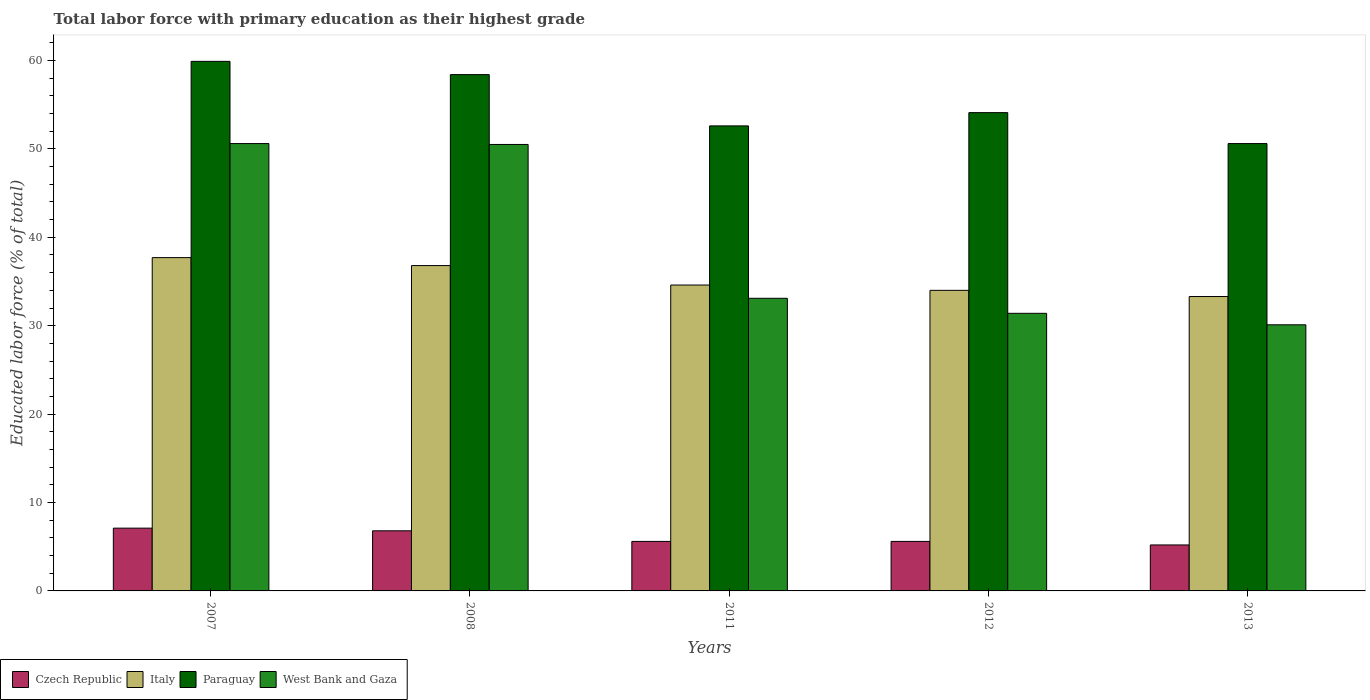How many groups of bars are there?
Offer a very short reply. 5. Are the number of bars on each tick of the X-axis equal?
Offer a very short reply. Yes. How many bars are there on the 5th tick from the right?
Give a very brief answer. 4. In how many cases, is the number of bars for a given year not equal to the number of legend labels?
Offer a very short reply. 0. What is the percentage of total labor force with primary education in West Bank and Gaza in 2013?
Your answer should be compact. 30.1. Across all years, what is the maximum percentage of total labor force with primary education in West Bank and Gaza?
Your response must be concise. 50.6. Across all years, what is the minimum percentage of total labor force with primary education in West Bank and Gaza?
Offer a terse response. 30.1. In which year was the percentage of total labor force with primary education in West Bank and Gaza maximum?
Give a very brief answer. 2007. In which year was the percentage of total labor force with primary education in Italy minimum?
Give a very brief answer. 2013. What is the total percentage of total labor force with primary education in West Bank and Gaza in the graph?
Offer a very short reply. 195.7. What is the difference between the percentage of total labor force with primary education in West Bank and Gaza in 2011 and that in 2013?
Offer a very short reply. 3. What is the difference between the percentage of total labor force with primary education in Italy in 2012 and the percentage of total labor force with primary education in West Bank and Gaza in 2013?
Keep it short and to the point. 3.9. What is the average percentage of total labor force with primary education in Paraguay per year?
Your answer should be very brief. 55.12. In the year 2012, what is the difference between the percentage of total labor force with primary education in West Bank and Gaza and percentage of total labor force with primary education in Paraguay?
Provide a short and direct response. -22.7. What is the ratio of the percentage of total labor force with primary education in West Bank and Gaza in 2011 to that in 2012?
Give a very brief answer. 1.05. Is the percentage of total labor force with primary education in Paraguay in 2008 less than that in 2011?
Provide a succinct answer. No. Is the difference between the percentage of total labor force with primary education in West Bank and Gaza in 2007 and 2012 greater than the difference between the percentage of total labor force with primary education in Paraguay in 2007 and 2012?
Provide a short and direct response. Yes. What is the difference between the highest and the second highest percentage of total labor force with primary education in Czech Republic?
Offer a terse response. 0.3. What is the difference between the highest and the lowest percentage of total labor force with primary education in Italy?
Make the answer very short. 4.4. Is it the case that in every year, the sum of the percentage of total labor force with primary education in West Bank and Gaza and percentage of total labor force with primary education in Italy is greater than the sum of percentage of total labor force with primary education in Paraguay and percentage of total labor force with primary education in Czech Republic?
Your response must be concise. No. What does the 4th bar from the left in 2008 represents?
Make the answer very short. West Bank and Gaza. Does the graph contain grids?
Offer a very short reply. No. What is the title of the graph?
Provide a short and direct response. Total labor force with primary education as their highest grade. Does "Afghanistan" appear as one of the legend labels in the graph?
Make the answer very short. No. What is the label or title of the X-axis?
Provide a succinct answer. Years. What is the label or title of the Y-axis?
Ensure brevity in your answer.  Educated labor force (% of total). What is the Educated labor force (% of total) of Czech Republic in 2007?
Keep it short and to the point. 7.1. What is the Educated labor force (% of total) in Italy in 2007?
Keep it short and to the point. 37.7. What is the Educated labor force (% of total) in Paraguay in 2007?
Make the answer very short. 59.9. What is the Educated labor force (% of total) of West Bank and Gaza in 2007?
Keep it short and to the point. 50.6. What is the Educated labor force (% of total) of Czech Republic in 2008?
Keep it short and to the point. 6.8. What is the Educated labor force (% of total) in Italy in 2008?
Ensure brevity in your answer.  36.8. What is the Educated labor force (% of total) of Paraguay in 2008?
Ensure brevity in your answer.  58.4. What is the Educated labor force (% of total) in West Bank and Gaza in 2008?
Provide a short and direct response. 50.5. What is the Educated labor force (% of total) of Czech Republic in 2011?
Your answer should be very brief. 5.6. What is the Educated labor force (% of total) of Italy in 2011?
Provide a short and direct response. 34.6. What is the Educated labor force (% of total) of Paraguay in 2011?
Your answer should be very brief. 52.6. What is the Educated labor force (% of total) in West Bank and Gaza in 2011?
Keep it short and to the point. 33.1. What is the Educated labor force (% of total) in Czech Republic in 2012?
Make the answer very short. 5.6. What is the Educated labor force (% of total) of Italy in 2012?
Your answer should be compact. 34. What is the Educated labor force (% of total) in Paraguay in 2012?
Give a very brief answer. 54.1. What is the Educated labor force (% of total) in West Bank and Gaza in 2012?
Make the answer very short. 31.4. What is the Educated labor force (% of total) in Czech Republic in 2013?
Keep it short and to the point. 5.2. What is the Educated labor force (% of total) in Italy in 2013?
Provide a succinct answer. 33.3. What is the Educated labor force (% of total) of Paraguay in 2013?
Offer a terse response. 50.6. What is the Educated labor force (% of total) of West Bank and Gaza in 2013?
Your answer should be compact. 30.1. Across all years, what is the maximum Educated labor force (% of total) of Czech Republic?
Ensure brevity in your answer.  7.1. Across all years, what is the maximum Educated labor force (% of total) in Italy?
Your answer should be compact. 37.7. Across all years, what is the maximum Educated labor force (% of total) in Paraguay?
Offer a terse response. 59.9. Across all years, what is the maximum Educated labor force (% of total) in West Bank and Gaza?
Make the answer very short. 50.6. Across all years, what is the minimum Educated labor force (% of total) of Czech Republic?
Offer a terse response. 5.2. Across all years, what is the minimum Educated labor force (% of total) of Italy?
Your answer should be very brief. 33.3. Across all years, what is the minimum Educated labor force (% of total) in Paraguay?
Keep it short and to the point. 50.6. Across all years, what is the minimum Educated labor force (% of total) in West Bank and Gaza?
Your answer should be compact. 30.1. What is the total Educated labor force (% of total) of Czech Republic in the graph?
Your answer should be compact. 30.3. What is the total Educated labor force (% of total) in Italy in the graph?
Provide a short and direct response. 176.4. What is the total Educated labor force (% of total) in Paraguay in the graph?
Offer a terse response. 275.6. What is the total Educated labor force (% of total) in West Bank and Gaza in the graph?
Ensure brevity in your answer.  195.7. What is the difference between the Educated labor force (% of total) in West Bank and Gaza in 2007 and that in 2008?
Provide a succinct answer. 0.1. What is the difference between the Educated labor force (% of total) in Italy in 2007 and that in 2011?
Your answer should be compact. 3.1. What is the difference between the Educated labor force (% of total) of Paraguay in 2007 and that in 2011?
Ensure brevity in your answer.  7.3. What is the difference between the Educated labor force (% of total) in West Bank and Gaza in 2007 and that in 2011?
Ensure brevity in your answer.  17.5. What is the difference between the Educated labor force (% of total) of West Bank and Gaza in 2007 and that in 2012?
Make the answer very short. 19.2. What is the difference between the Educated labor force (% of total) of Italy in 2007 and that in 2013?
Offer a terse response. 4.4. What is the difference between the Educated labor force (% of total) of West Bank and Gaza in 2007 and that in 2013?
Your response must be concise. 20.5. What is the difference between the Educated labor force (% of total) in Czech Republic in 2008 and that in 2011?
Your answer should be compact. 1.2. What is the difference between the Educated labor force (% of total) in Italy in 2008 and that in 2011?
Offer a terse response. 2.2. What is the difference between the Educated labor force (% of total) of Paraguay in 2008 and that in 2011?
Offer a very short reply. 5.8. What is the difference between the Educated labor force (% of total) of Paraguay in 2008 and that in 2012?
Your answer should be compact. 4.3. What is the difference between the Educated labor force (% of total) of West Bank and Gaza in 2008 and that in 2012?
Make the answer very short. 19.1. What is the difference between the Educated labor force (% of total) of Czech Republic in 2008 and that in 2013?
Provide a short and direct response. 1.6. What is the difference between the Educated labor force (% of total) of Paraguay in 2008 and that in 2013?
Your answer should be very brief. 7.8. What is the difference between the Educated labor force (% of total) in West Bank and Gaza in 2008 and that in 2013?
Your answer should be compact. 20.4. What is the difference between the Educated labor force (% of total) of Czech Republic in 2011 and that in 2012?
Your answer should be compact. 0. What is the difference between the Educated labor force (% of total) of Czech Republic in 2011 and that in 2013?
Offer a terse response. 0.4. What is the difference between the Educated labor force (% of total) of Italy in 2011 and that in 2013?
Offer a very short reply. 1.3. What is the difference between the Educated labor force (% of total) in West Bank and Gaza in 2011 and that in 2013?
Provide a short and direct response. 3. What is the difference between the Educated labor force (% of total) of Czech Republic in 2012 and that in 2013?
Give a very brief answer. 0.4. What is the difference between the Educated labor force (% of total) in Paraguay in 2012 and that in 2013?
Provide a succinct answer. 3.5. What is the difference between the Educated labor force (% of total) in Czech Republic in 2007 and the Educated labor force (% of total) in Italy in 2008?
Provide a succinct answer. -29.7. What is the difference between the Educated labor force (% of total) in Czech Republic in 2007 and the Educated labor force (% of total) in Paraguay in 2008?
Offer a terse response. -51.3. What is the difference between the Educated labor force (% of total) in Czech Republic in 2007 and the Educated labor force (% of total) in West Bank and Gaza in 2008?
Offer a terse response. -43.4. What is the difference between the Educated labor force (% of total) of Italy in 2007 and the Educated labor force (% of total) of Paraguay in 2008?
Your answer should be very brief. -20.7. What is the difference between the Educated labor force (% of total) of Paraguay in 2007 and the Educated labor force (% of total) of West Bank and Gaza in 2008?
Your answer should be compact. 9.4. What is the difference between the Educated labor force (% of total) in Czech Republic in 2007 and the Educated labor force (% of total) in Italy in 2011?
Provide a succinct answer. -27.5. What is the difference between the Educated labor force (% of total) in Czech Republic in 2007 and the Educated labor force (% of total) in Paraguay in 2011?
Offer a terse response. -45.5. What is the difference between the Educated labor force (% of total) in Czech Republic in 2007 and the Educated labor force (% of total) in West Bank and Gaza in 2011?
Give a very brief answer. -26. What is the difference between the Educated labor force (% of total) of Italy in 2007 and the Educated labor force (% of total) of Paraguay in 2011?
Offer a very short reply. -14.9. What is the difference between the Educated labor force (% of total) of Paraguay in 2007 and the Educated labor force (% of total) of West Bank and Gaza in 2011?
Your response must be concise. 26.8. What is the difference between the Educated labor force (% of total) of Czech Republic in 2007 and the Educated labor force (% of total) of Italy in 2012?
Provide a short and direct response. -26.9. What is the difference between the Educated labor force (% of total) of Czech Republic in 2007 and the Educated labor force (% of total) of Paraguay in 2012?
Provide a short and direct response. -47. What is the difference between the Educated labor force (% of total) in Czech Republic in 2007 and the Educated labor force (% of total) in West Bank and Gaza in 2012?
Make the answer very short. -24.3. What is the difference between the Educated labor force (% of total) in Italy in 2007 and the Educated labor force (% of total) in Paraguay in 2012?
Provide a short and direct response. -16.4. What is the difference between the Educated labor force (% of total) of Paraguay in 2007 and the Educated labor force (% of total) of West Bank and Gaza in 2012?
Your answer should be compact. 28.5. What is the difference between the Educated labor force (% of total) of Czech Republic in 2007 and the Educated labor force (% of total) of Italy in 2013?
Your answer should be very brief. -26.2. What is the difference between the Educated labor force (% of total) of Czech Republic in 2007 and the Educated labor force (% of total) of Paraguay in 2013?
Provide a succinct answer. -43.5. What is the difference between the Educated labor force (% of total) in Czech Republic in 2007 and the Educated labor force (% of total) in West Bank and Gaza in 2013?
Your response must be concise. -23. What is the difference between the Educated labor force (% of total) in Paraguay in 2007 and the Educated labor force (% of total) in West Bank and Gaza in 2013?
Provide a succinct answer. 29.8. What is the difference between the Educated labor force (% of total) of Czech Republic in 2008 and the Educated labor force (% of total) of Italy in 2011?
Offer a very short reply. -27.8. What is the difference between the Educated labor force (% of total) in Czech Republic in 2008 and the Educated labor force (% of total) in Paraguay in 2011?
Your answer should be compact. -45.8. What is the difference between the Educated labor force (% of total) of Czech Republic in 2008 and the Educated labor force (% of total) of West Bank and Gaza in 2011?
Your response must be concise. -26.3. What is the difference between the Educated labor force (% of total) of Italy in 2008 and the Educated labor force (% of total) of Paraguay in 2011?
Your answer should be very brief. -15.8. What is the difference between the Educated labor force (% of total) in Italy in 2008 and the Educated labor force (% of total) in West Bank and Gaza in 2011?
Your answer should be compact. 3.7. What is the difference between the Educated labor force (% of total) in Paraguay in 2008 and the Educated labor force (% of total) in West Bank and Gaza in 2011?
Provide a succinct answer. 25.3. What is the difference between the Educated labor force (% of total) in Czech Republic in 2008 and the Educated labor force (% of total) in Italy in 2012?
Your response must be concise. -27.2. What is the difference between the Educated labor force (% of total) of Czech Republic in 2008 and the Educated labor force (% of total) of Paraguay in 2012?
Make the answer very short. -47.3. What is the difference between the Educated labor force (% of total) in Czech Republic in 2008 and the Educated labor force (% of total) in West Bank and Gaza in 2012?
Make the answer very short. -24.6. What is the difference between the Educated labor force (% of total) in Italy in 2008 and the Educated labor force (% of total) in Paraguay in 2012?
Offer a terse response. -17.3. What is the difference between the Educated labor force (% of total) in Italy in 2008 and the Educated labor force (% of total) in West Bank and Gaza in 2012?
Provide a succinct answer. 5.4. What is the difference between the Educated labor force (% of total) in Paraguay in 2008 and the Educated labor force (% of total) in West Bank and Gaza in 2012?
Provide a succinct answer. 27. What is the difference between the Educated labor force (% of total) of Czech Republic in 2008 and the Educated labor force (% of total) of Italy in 2013?
Keep it short and to the point. -26.5. What is the difference between the Educated labor force (% of total) in Czech Republic in 2008 and the Educated labor force (% of total) in Paraguay in 2013?
Make the answer very short. -43.8. What is the difference between the Educated labor force (% of total) in Czech Republic in 2008 and the Educated labor force (% of total) in West Bank and Gaza in 2013?
Provide a short and direct response. -23.3. What is the difference between the Educated labor force (% of total) of Italy in 2008 and the Educated labor force (% of total) of Paraguay in 2013?
Your answer should be compact. -13.8. What is the difference between the Educated labor force (% of total) in Italy in 2008 and the Educated labor force (% of total) in West Bank and Gaza in 2013?
Make the answer very short. 6.7. What is the difference between the Educated labor force (% of total) of Paraguay in 2008 and the Educated labor force (% of total) of West Bank and Gaza in 2013?
Keep it short and to the point. 28.3. What is the difference between the Educated labor force (% of total) of Czech Republic in 2011 and the Educated labor force (% of total) of Italy in 2012?
Your answer should be compact. -28.4. What is the difference between the Educated labor force (% of total) of Czech Republic in 2011 and the Educated labor force (% of total) of Paraguay in 2012?
Keep it short and to the point. -48.5. What is the difference between the Educated labor force (% of total) in Czech Republic in 2011 and the Educated labor force (% of total) in West Bank and Gaza in 2012?
Offer a terse response. -25.8. What is the difference between the Educated labor force (% of total) in Italy in 2011 and the Educated labor force (% of total) in Paraguay in 2012?
Give a very brief answer. -19.5. What is the difference between the Educated labor force (% of total) in Paraguay in 2011 and the Educated labor force (% of total) in West Bank and Gaza in 2012?
Your answer should be very brief. 21.2. What is the difference between the Educated labor force (% of total) in Czech Republic in 2011 and the Educated labor force (% of total) in Italy in 2013?
Provide a succinct answer. -27.7. What is the difference between the Educated labor force (% of total) in Czech Republic in 2011 and the Educated labor force (% of total) in Paraguay in 2013?
Your answer should be very brief. -45. What is the difference between the Educated labor force (% of total) of Czech Republic in 2011 and the Educated labor force (% of total) of West Bank and Gaza in 2013?
Keep it short and to the point. -24.5. What is the difference between the Educated labor force (% of total) in Italy in 2011 and the Educated labor force (% of total) in Paraguay in 2013?
Give a very brief answer. -16. What is the difference between the Educated labor force (% of total) of Italy in 2011 and the Educated labor force (% of total) of West Bank and Gaza in 2013?
Ensure brevity in your answer.  4.5. What is the difference between the Educated labor force (% of total) in Paraguay in 2011 and the Educated labor force (% of total) in West Bank and Gaza in 2013?
Ensure brevity in your answer.  22.5. What is the difference between the Educated labor force (% of total) of Czech Republic in 2012 and the Educated labor force (% of total) of Italy in 2013?
Your response must be concise. -27.7. What is the difference between the Educated labor force (% of total) of Czech Republic in 2012 and the Educated labor force (% of total) of Paraguay in 2013?
Offer a very short reply. -45. What is the difference between the Educated labor force (% of total) in Czech Republic in 2012 and the Educated labor force (% of total) in West Bank and Gaza in 2013?
Your answer should be compact. -24.5. What is the difference between the Educated labor force (% of total) of Italy in 2012 and the Educated labor force (% of total) of Paraguay in 2013?
Your answer should be very brief. -16.6. What is the difference between the Educated labor force (% of total) of Italy in 2012 and the Educated labor force (% of total) of West Bank and Gaza in 2013?
Keep it short and to the point. 3.9. What is the average Educated labor force (% of total) of Czech Republic per year?
Provide a succinct answer. 6.06. What is the average Educated labor force (% of total) in Italy per year?
Provide a succinct answer. 35.28. What is the average Educated labor force (% of total) of Paraguay per year?
Give a very brief answer. 55.12. What is the average Educated labor force (% of total) of West Bank and Gaza per year?
Offer a very short reply. 39.14. In the year 2007, what is the difference between the Educated labor force (% of total) of Czech Republic and Educated labor force (% of total) of Italy?
Give a very brief answer. -30.6. In the year 2007, what is the difference between the Educated labor force (% of total) of Czech Republic and Educated labor force (% of total) of Paraguay?
Give a very brief answer. -52.8. In the year 2007, what is the difference between the Educated labor force (% of total) of Czech Republic and Educated labor force (% of total) of West Bank and Gaza?
Offer a terse response. -43.5. In the year 2007, what is the difference between the Educated labor force (% of total) in Italy and Educated labor force (% of total) in Paraguay?
Give a very brief answer. -22.2. In the year 2008, what is the difference between the Educated labor force (% of total) in Czech Republic and Educated labor force (% of total) in Paraguay?
Your response must be concise. -51.6. In the year 2008, what is the difference between the Educated labor force (% of total) in Czech Republic and Educated labor force (% of total) in West Bank and Gaza?
Your answer should be compact. -43.7. In the year 2008, what is the difference between the Educated labor force (% of total) in Italy and Educated labor force (% of total) in Paraguay?
Offer a terse response. -21.6. In the year 2008, what is the difference between the Educated labor force (% of total) in Italy and Educated labor force (% of total) in West Bank and Gaza?
Offer a very short reply. -13.7. In the year 2008, what is the difference between the Educated labor force (% of total) of Paraguay and Educated labor force (% of total) of West Bank and Gaza?
Your answer should be very brief. 7.9. In the year 2011, what is the difference between the Educated labor force (% of total) in Czech Republic and Educated labor force (% of total) in Paraguay?
Give a very brief answer. -47. In the year 2011, what is the difference between the Educated labor force (% of total) in Czech Republic and Educated labor force (% of total) in West Bank and Gaza?
Make the answer very short. -27.5. In the year 2011, what is the difference between the Educated labor force (% of total) of Italy and Educated labor force (% of total) of West Bank and Gaza?
Provide a short and direct response. 1.5. In the year 2012, what is the difference between the Educated labor force (% of total) of Czech Republic and Educated labor force (% of total) of Italy?
Make the answer very short. -28.4. In the year 2012, what is the difference between the Educated labor force (% of total) in Czech Republic and Educated labor force (% of total) in Paraguay?
Make the answer very short. -48.5. In the year 2012, what is the difference between the Educated labor force (% of total) of Czech Republic and Educated labor force (% of total) of West Bank and Gaza?
Ensure brevity in your answer.  -25.8. In the year 2012, what is the difference between the Educated labor force (% of total) of Italy and Educated labor force (% of total) of Paraguay?
Provide a succinct answer. -20.1. In the year 2012, what is the difference between the Educated labor force (% of total) of Paraguay and Educated labor force (% of total) of West Bank and Gaza?
Offer a terse response. 22.7. In the year 2013, what is the difference between the Educated labor force (% of total) in Czech Republic and Educated labor force (% of total) in Italy?
Provide a succinct answer. -28.1. In the year 2013, what is the difference between the Educated labor force (% of total) of Czech Republic and Educated labor force (% of total) of Paraguay?
Provide a succinct answer. -45.4. In the year 2013, what is the difference between the Educated labor force (% of total) in Czech Republic and Educated labor force (% of total) in West Bank and Gaza?
Make the answer very short. -24.9. In the year 2013, what is the difference between the Educated labor force (% of total) in Italy and Educated labor force (% of total) in Paraguay?
Offer a very short reply. -17.3. In the year 2013, what is the difference between the Educated labor force (% of total) of Italy and Educated labor force (% of total) of West Bank and Gaza?
Ensure brevity in your answer.  3.2. In the year 2013, what is the difference between the Educated labor force (% of total) of Paraguay and Educated labor force (% of total) of West Bank and Gaza?
Make the answer very short. 20.5. What is the ratio of the Educated labor force (% of total) of Czech Republic in 2007 to that in 2008?
Provide a succinct answer. 1.04. What is the ratio of the Educated labor force (% of total) in Italy in 2007 to that in 2008?
Offer a very short reply. 1.02. What is the ratio of the Educated labor force (% of total) in Paraguay in 2007 to that in 2008?
Make the answer very short. 1.03. What is the ratio of the Educated labor force (% of total) in West Bank and Gaza in 2007 to that in 2008?
Keep it short and to the point. 1. What is the ratio of the Educated labor force (% of total) of Czech Republic in 2007 to that in 2011?
Your answer should be compact. 1.27. What is the ratio of the Educated labor force (% of total) in Italy in 2007 to that in 2011?
Ensure brevity in your answer.  1.09. What is the ratio of the Educated labor force (% of total) in Paraguay in 2007 to that in 2011?
Your response must be concise. 1.14. What is the ratio of the Educated labor force (% of total) in West Bank and Gaza in 2007 to that in 2011?
Your answer should be very brief. 1.53. What is the ratio of the Educated labor force (% of total) of Czech Republic in 2007 to that in 2012?
Offer a terse response. 1.27. What is the ratio of the Educated labor force (% of total) in Italy in 2007 to that in 2012?
Provide a short and direct response. 1.11. What is the ratio of the Educated labor force (% of total) in Paraguay in 2007 to that in 2012?
Keep it short and to the point. 1.11. What is the ratio of the Educated labor force (% of total) in West Bank and Gaza in 2007 to that in 2012?
Make the answer very short. 1.61. What is the ratio of the Educated labor force (% of total) of Czech Republic in 2007 to that in 2013?
Offer a very short reply. 1.37. What is the ratio of the Educated labor force (% of total) of Italy in 2007 to that in 2013?
Your response must be concise. 1.13. What is the ratio of the Educated labor force (% of total) in Paraguay in 2007 to that in 2013?
Your answer should be very brief. 1.18. What is the ratio of the Educated labor force (% of total) of West Bank and Gaza in 2007 to that in 2013?
Provide a short and direct response. 1.68. What is the ratio of the Educated labor force (% of total) in Czech Republic in 2008 to that in 2011?
Provide a succinct answer. 1.21. What is the ratio of the Educated labor force (% of total) in Italy in 2008 to that in 2011?
Make the answer very short. 1.06. What is the ratio of the Educated labor force (% of total) in Paraguay in 2008 to that in 2011?
Your answer should be compact. 1.11. What is the ratio of the Educated labor force (% of total) in West Bank and Gaza in 2008 to that in 2011?
Offer a very short reply. 1.53. What is the ratio of the Educated labor force (% of total) in Czech Republic in 2008 to that in 2012?
Your answer should be very brief. 1.21. What is the ratio of the Educated labor force (% of total) of Italy in 2008 to that in 2012?
Offer a terse response. 1.08. What is the ratio of the Educated labor force (% of total) in Paraguay in 2008 to that in 2012?
Your answer should be very brief. 1.08. What is the ratio of the Educated labor force (% of total) in West Bank and Gaza in 2008 to that in 2012?
Provide a succinct answer. 1.61. What is the ratio of the Educated labor force (% of total) in Czech Republic in 2008 to that in 2013?
Ensure brevity in your answer.  1.31. What is the ratio of the Educated labor force (% of total) of Italy in 2008 to that in 2013?
Keep it short and to the point. 1.11. What is the ratio of the Educated labor force (% of total) of Paraguay in 2008 to that in 2013?
Provide a short and direct response. 1.15. What is the ratio of the Educated labor force (% of total) of West Bank and Gaza in 2008 to that in 2013?
Offer a very short reply. 1.68. What is the ratio of the Educated labor force (% of total) of Italy in 2011 to that in 2012?
Offer a very short reply. 1.02. What is the ratio of the Educated labor force (% of total) of Paraguay in 2011 to that in 2012?
Offer a very short reply. 0.97. What is the ratio of the Educated labor force (% of total) of West Bank and Gaza in 2011 to that in 2012?
Your answer should be compact. 1.05. What is the ratio of the Educated labor force (% of total) of Czech Republic in 2011 to that in 2013?
Your answer should be very brief. 1.08. What is the ratio of the Educated labor force (% of total) of Italy in 2011 to that in 2013?
Provide a short and direct response. 1.04. What is the ratio of the Educated labor force (% of total) of Paraguay in 2011 to that in 2013?
Keep it short and to the point. 1.04. What is the ratio of the Educated labor force (% of total) of West Bank and Gaza in 2011 to that in 2013?
Ensure brevity in your answer.  1.1. What is the ratio of the Educated labor force (% of total) of Czech Republic in 2012 to that in 2013?
Your answer should be very brief. 1.08. What is the ratio of the Educated labor force (% of total) of Italy in 2012 to that in 2013?
Provide a succinct answer. 1.02. What is the ratio of the Educated labor force (% of total) of Paraguay in 2012 to that in 2013?
Your answer should be very brief. 1.07. What is the ratio of the Educated labor force (% of total) of West Bank and Gaza in 2012 to that in 2013?
Keep it short and to the point. 1.04. What is the difference between the highest and the second highest Educated labor force (% of total) of West Bank and Gaza?
Keep it short and to the point. 0.1. What is the difference between the highest and the lowest Educated labor force (% of total) of Paraguay?
Ensure brevity in your answer.  9.3. 